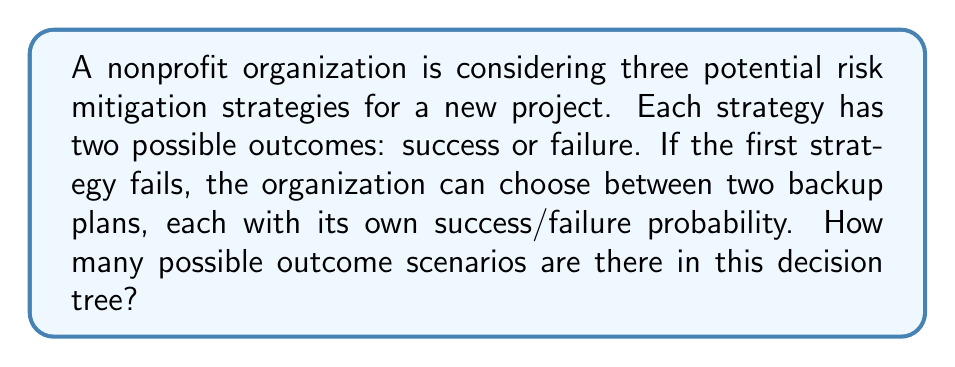Show me your answer to this math problem. Let's approach this step-by-step:

1) First, consider the initial strategy:
   - It has 2 possible outcomes (success or failure)

2) If the initial strategy succeeds, that's one complete path in the decision tree.

3) If the initial strategy fails, we have two backup plans:
   - Each backup plan has 2 possible outcomes (success or failure)

4) We can represent this as a decision tree:

   ```
   Initial Strategy ---> Success (1 outcome)
                   |
                   |--> Failure ---> Backup Plan 1 ---> Success (1 outcome)
                                |                  |
                                |                  |--> Failure (1 outcome)
                                |
                                |--> Backup Plan 2 ---> Success (1 outcome)
                                                   |
                                                   |--> Failure (1 outcome)
   ```

5) To count the total number of possible outcomes, we sum up all the leaf nodes in our decision tree:
   
   $$ \text{Total Outcomes} = 1 + (2 \times 2) = 1 + 4 = 5 $$

   - 1 outcome from the success of the initial strategy
   - 4 outcomes from the failure of the initial strategy (2 backup plans × 2 outcomes each)

Therefore, there are 5 possible outcome scenarios in this decision tree.
Answer: 5 possible outcomes 